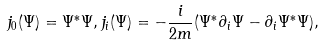<formula> <loc_0><loc_0><loc_500><loc_500>j _ { 0 } ( \Psi ) = \Psi ^ { * } \Psi , j _ { i } ( \Psi ) = - \frac { i } { 2 m } ( \Psi ^ { * } \partial _ { i } \Psi - \partial _ { i } \Psi ^ { * } \Psi ) ,</formula> 